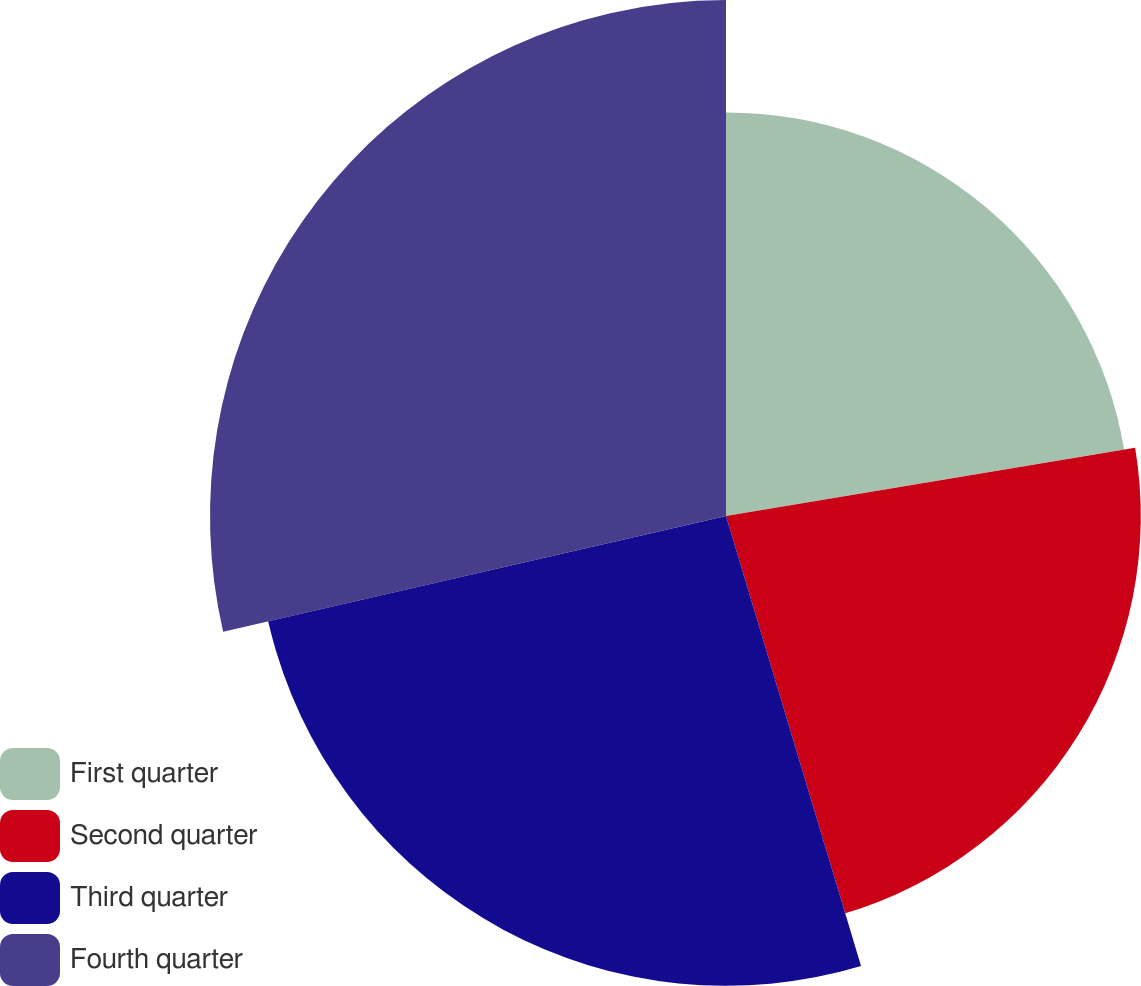Convert chart. <chart><loc_0><loc_0><loc_500><loc_500><pie_chart><fcel>First quarter<fcel>Second quarter<fcel>Third quarter<fcel>Fourth quarter<nl><fcel>22.37%<fcel>22.99%<fcel>26.04%<fcel>28.6%<nl></chart> 